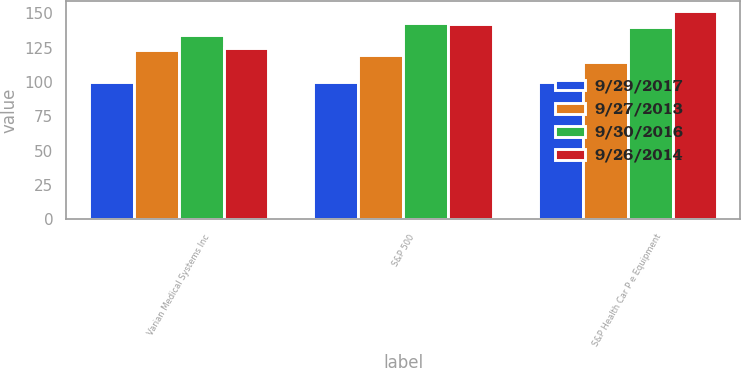<chart> <loc_0><loc_0><loc_500><loc_500><stacked_bar_chart><ecel><fcel>Varian Medical Systems Inc<fcel>S&P 500<fcel>S&P Health Car P e Equipment<nl><fcel>9/29/2017<fcel>100<fcel>100<fcel>100<nl><fcel>9/27/2013<fcel>122.98<fcel>119.34<fcel>114.92<nl><fcel>9/30/2016<fcel>134.12<fcel>142.89<fcel>139.91<nl><fcel>9/26/2014<fcel>124.65<fcel>142.02<fcel>151.75<nl></chart> 